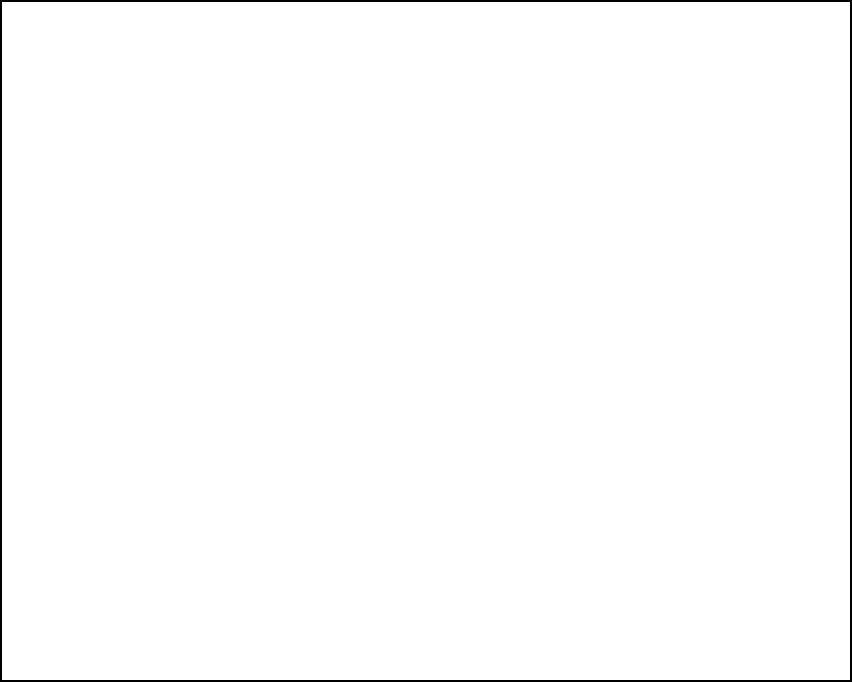In a stage blocking diagram, a character's silhouette is represented by a rectangular shape. The initial position of the character is shown in dark gray, and the rotated position is shown in light gray. If the character is rotated 90 degrees counterclockwise around the center of the stage (marked by the blue dot), what are the coordinates of point A (marked in red) after the rotation? To find the coordinates of point A after rotation, we can follow these steps:

1. Identify the initial coordinates of point A: $(2,1)$

2. Determine the center of rotation: $(0,0)$ (the blue dot at the center of the stage)

3. Apply the rotation formula for a 90-degree counterclockwise rotation around the origin:
   $(x', y') = (-y, x)$

4. Substitute the initial coordinates into the formula:
   $x' = -1$
   $y' = 2$

5. Therefore, the new coordinates of point A after rotation are $(-1, 2)$

We can verify this visually by observing that the rotated shape (light gray) has indeed moved the original point A (red dot) to the position $(-1, 2)$ on the stage diagram.
Answer: $(-1, 2)$ 